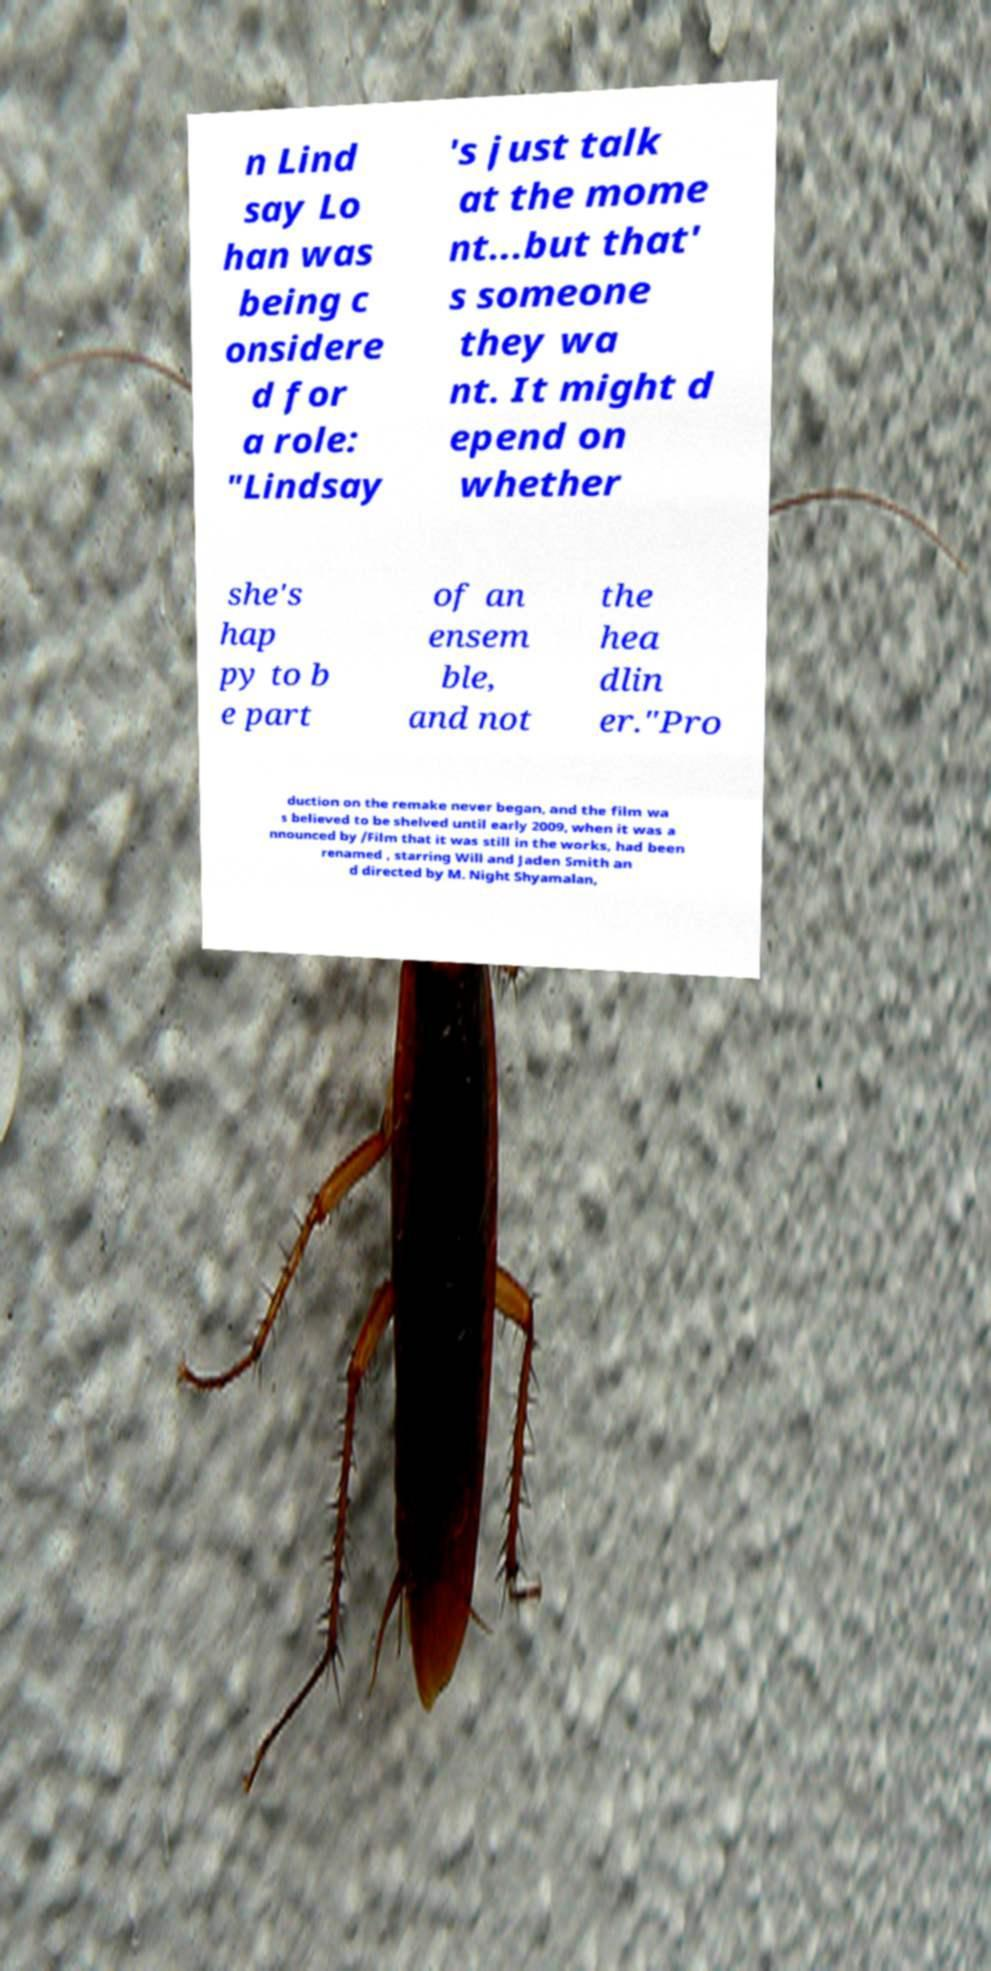I need the written content from this picture converted into text. Can you do that? n Lind say Lo han was being c onsidere d for a role: "Lindsay 's just talk at the mome nt...but that' s someone they wa nt. It might d epend on whether she's hap py to b e part of an ensem ble, and not the hea dlin er."Pro duction on the remake never began, and the film wa s believed to be shelved until early 2009, when it was a nnounced by /Film that it was still in the works, had been renamed , starring Will and Jaden Smith an d directed by M. Night Shyamalan, 